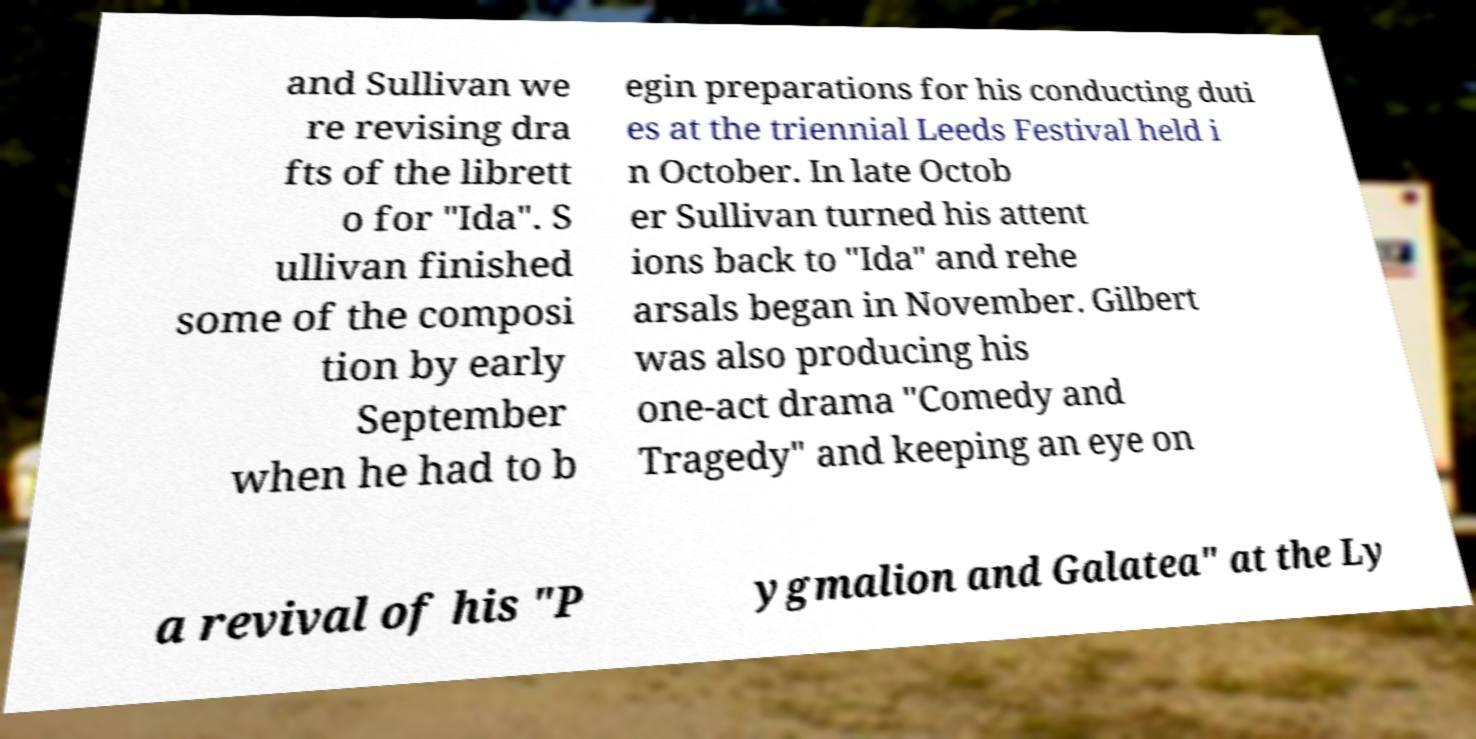What messages or text are displayed in this image? I need them in a readable, typed format. and Sullivan we re revising dra fts of the librett o for "Ida". S ullivan finished some of the composi tion by early September when he had to b egin preparations for his conducting duti es at the triennial Leeds Festival held i n October. In late Octob er Sullivan turned his attent ions back to "Ida" and rehe arsals began in November. Gilbert was also producing his one-act drama "Comedy and Tragedy" and keeping an eye on a revival of his "P ygmalion and Galatea" at the Ly 